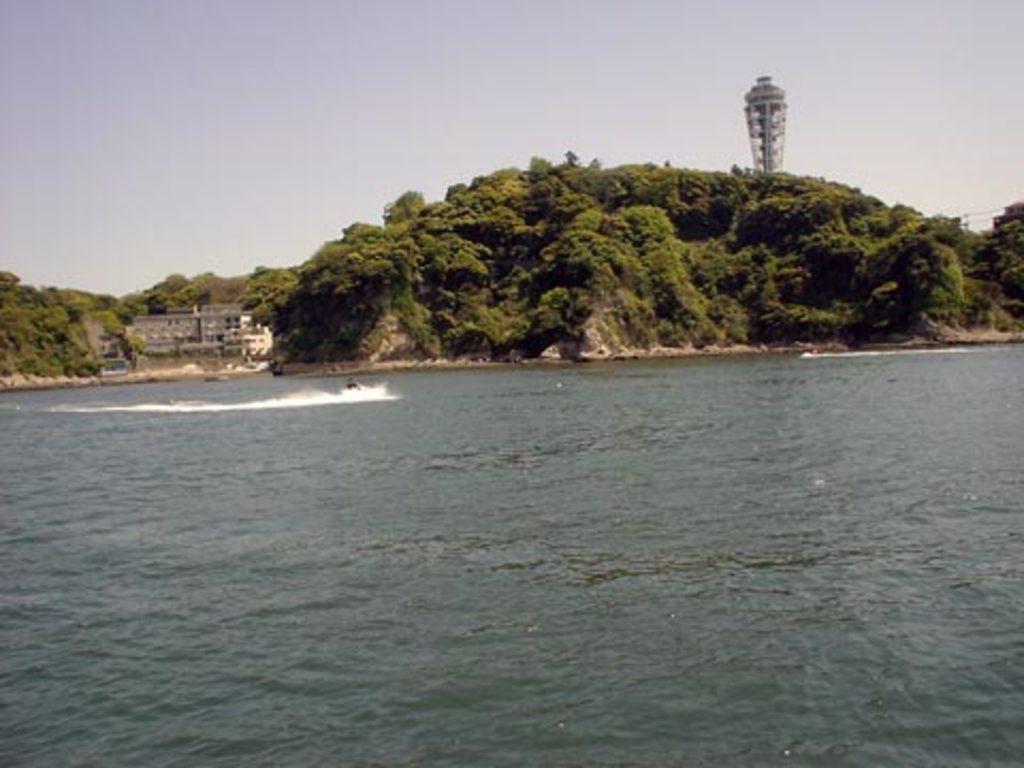Describe this image in one or two sentences. In this image we can see few people sailing on the watercraft. We can see the sea. We can see the sky. There are few hills in the image. There are many trees in the image. There is a building at the left side of the image. We can see a building at the right side of the image. 